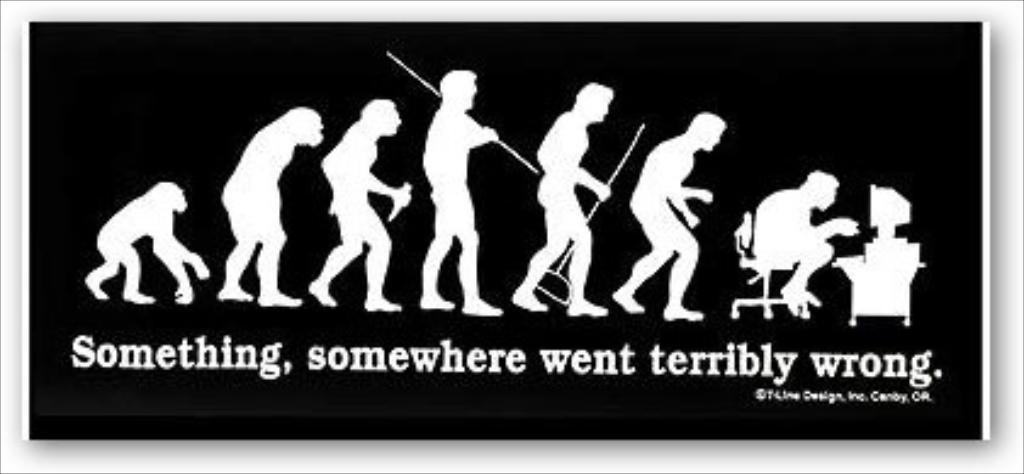<image>
Offer a succinct explanation of the picture presented. A sticker that reads Something, somewhere went terribly wrong. 